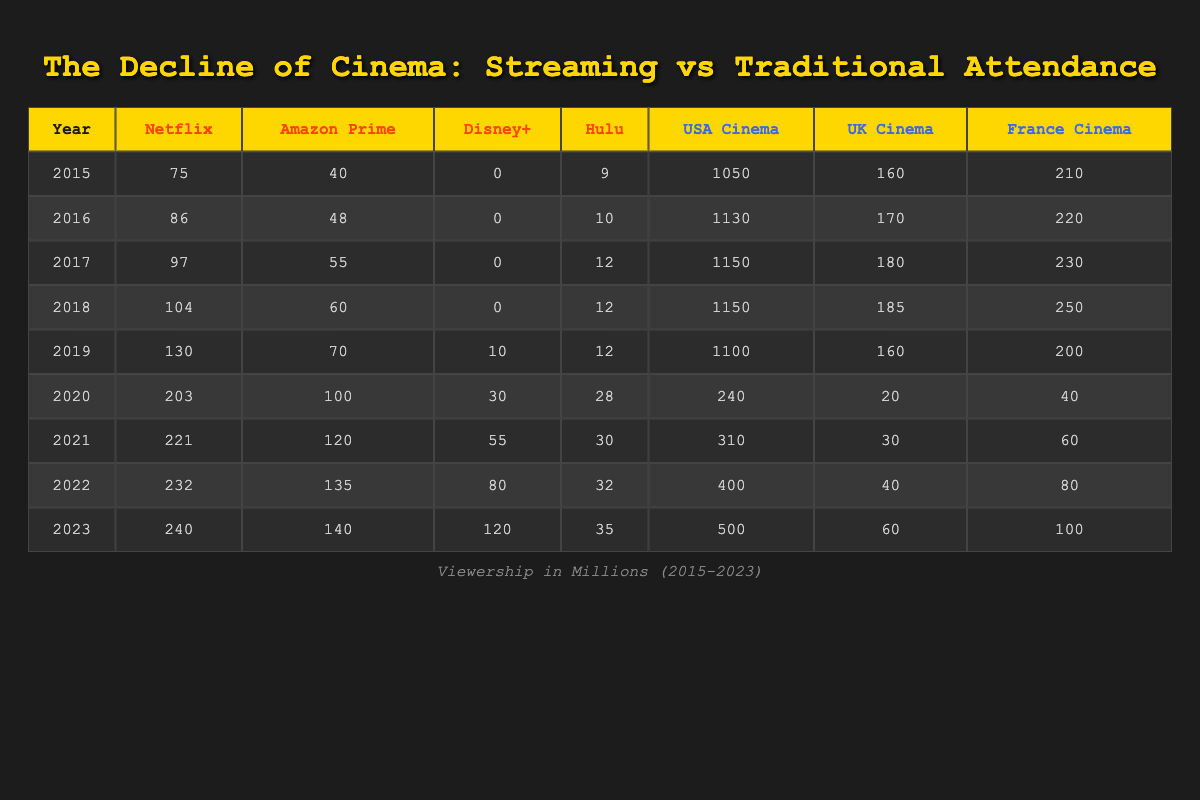What was the streaming service viewership for Netflix in 2020? The table shows that in 2020, Netflix had 203 million viewers. This can be directly retrieved from the row corresponding to the year 2020 and the column for Netflix.
Answer: 203 How much did Amazon Prime viewership grow from 2015 to 2023? To find the growth, we take the difference between the viewership in 2023 (140 million) and in 2015 (40 million). So, 140 - 40 = 100. This means Amazon Prime viewership grew by 100 million from 2015 to 2023.
Answer: 100 Which streaming service had the highest viewership in 2023? In 2023, Netflix had 240 million viewers, which is the highest compared to the other services: Amazon Prime (140 million), Disney+ (120 million), and Hulu (35 million). This is confirmed by comparing the final row of each service's viewership.
Answer: Netflix Is it true that traditional cinema attendance in the USA decreased from 2019 to 2020? Yes, the attendance in the USA was 1100 million in 2019 and dropped to 240 million in 2020. Thus, the statement is correct as it indicates a significant decline during that year.
Answer: Yes Calculate the total traditional cinema attendance in the UK from 2015 to 2023. The attendance values for the UK from 2015 to 2023 are: 160, 170, 180, 185, 160, 20, 30, 40, and 60. The total is calculated by summing these values: 160 + 170 + 180 + 185 + 160 + 20 + 30 + 40 + 60 = 1,015 million.
Answer: 1015 What was the viewership for Hulu in 2022? Referencing the table, the viewership for Hulu in 2022 is 32 million, which can be found in the row for 2022 in the Hulu column.
Answer: 32 How much more viewership did Disney+ gain from 2021 to 2023? Disney+ had 55 million viewers in 2021 and increased to 120 million in 2023. The increase is calculated by subtracting the two figures: 120 - 55 = 65 million.
Answer: 65 Did Hulu's viewership increase every year from 2015 to 2023? No, while Hulu's numbers seem to increase overall, it held steady at 12 million from 2017 to 2019, showing no growth for those years. Thus, the statement is not true.
Answer: No 